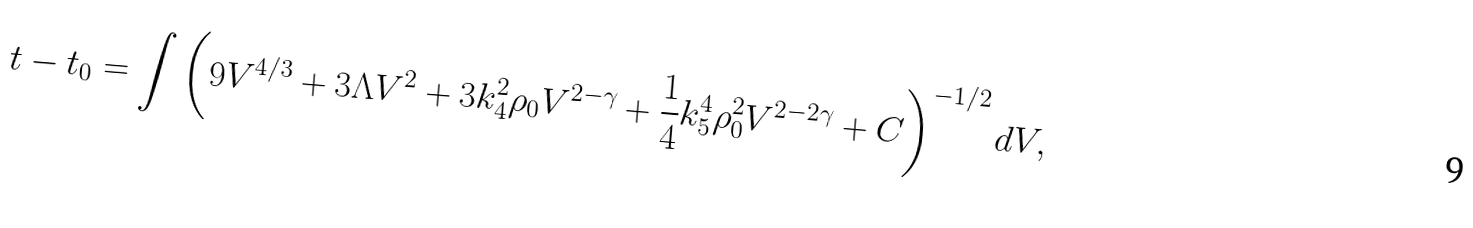<formula> <loc_0><loc_0><loc_500><loc_500>t - t _ { 0 } = \int \left ( 9 V ^ { 4 / 3 } + 3 \Lambda V ^ { 2 } + 3 k _ { 4 } ^ { 2 } \rho _ { 0 } V ^ { 2 - \gamma } + \frac { 1 } { 4 } k _ { 5 } ^ { 4 } \rho _ { 0 } ^ { 2 } V ^ { 2 - 2 \gamma } + C \right ) ^ { - 1 / 2 } d V ,</formula> 